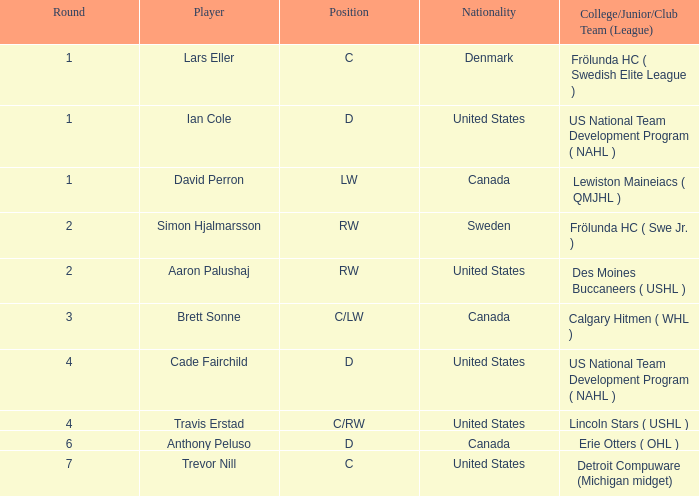Which college/junior/club team (league) did Brett Sonne play in? Calgary Hitmen ( WHL ). 